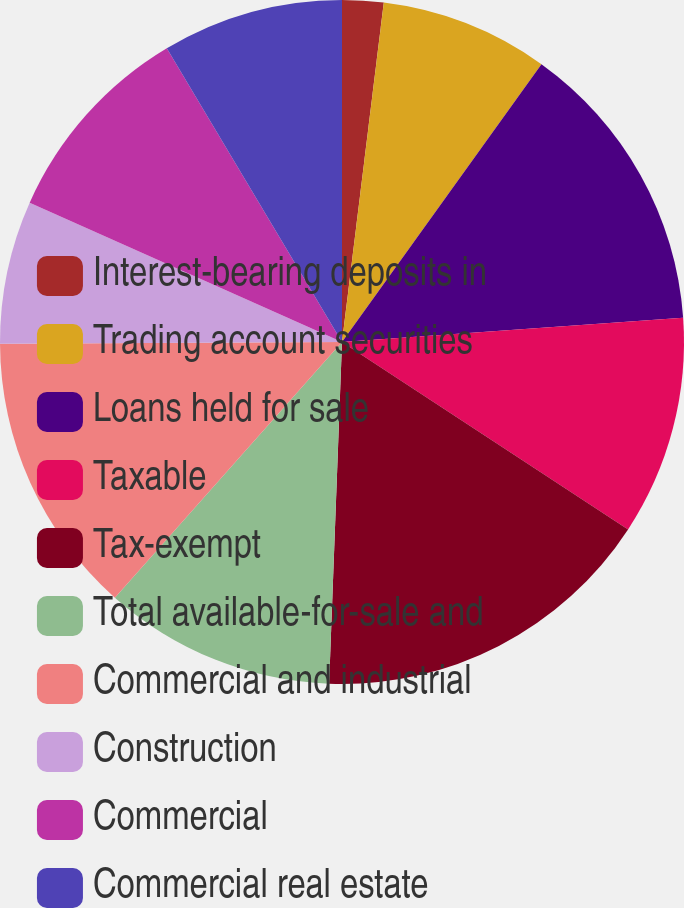Convert chart to OTSL. <chart><loc_0><loc_0><loc_500><loc_500><pie_chart><fcel>Interest-bearing deposits in<fcel>Trading account securities<fcel>Loans held for sale<fcel>Taxable<fcel>Tax-exempt<fcel>Total available-for-sale and<fcel>Commercial and industrial<fcel>Construction<fcel>Commercial<fcel>Commercial real estate<nl><fcel>1.95%<fcel>7.96%<fcel>13.96%<fcel>10.36%<fcel>16.37%<fcel>10.96%<fcel>13.36%<fcel>6.76%<fcel>9.76%<fcel>8.56%<nl></chart> 